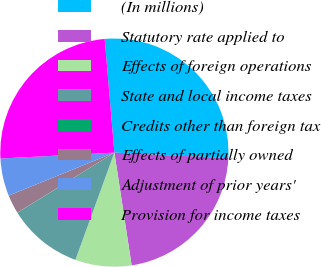<chart> <loc_0><loc_0><loc_500><loc_500><pie_chart><fcel>(In millions)<fcel>Statutory rate applied to<fcel>Effects of foreign operations<fcel>State and local income taxes<fcel>Credits other than foreign tax<fcel>Effects of partially owned<fcel>Adjustment of prior years'<fcel>Provision for income taxes<nl><fcel>27.12%<fcel>21.82%<fcel>7.96%<fcel>10.61%<fcel>0.03%<fcel>2.67%<fcel>5.32%<fcel>24.47%<nl></chart> 